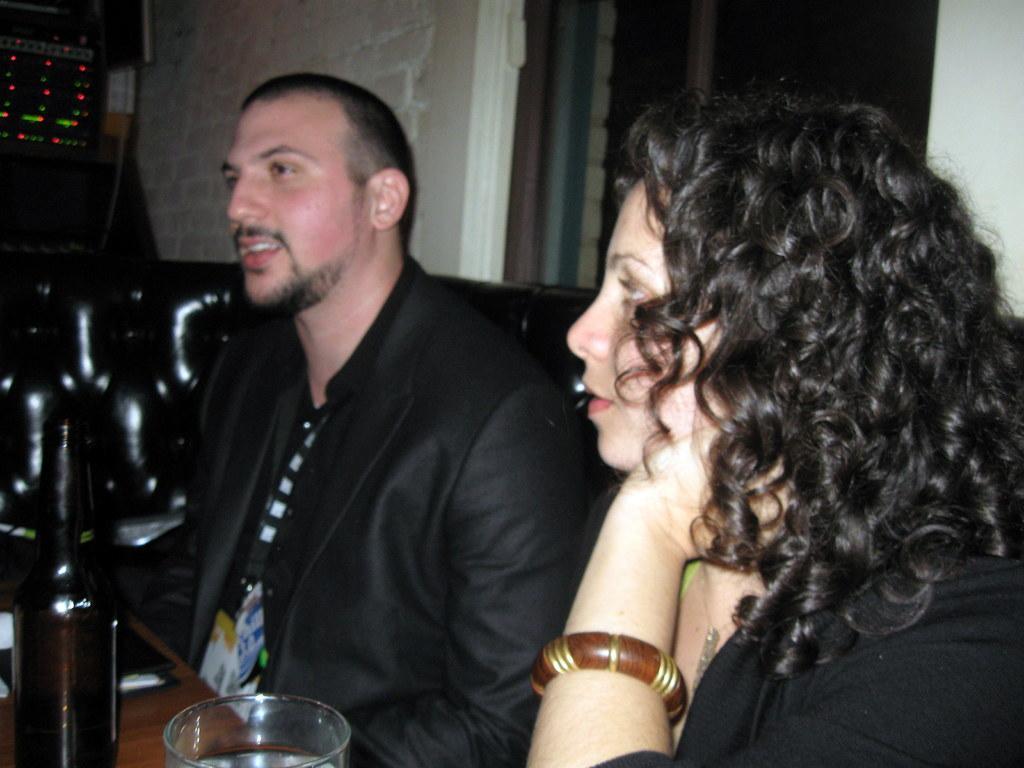Describe this image in one or two sentences. In the picture we can see a man and a woman sitting in the black cushion, they are in the black dresses and in front of them, we can see the table with a wine bottle and a glass of water and behind the cushion we can see the wall and an exit. 